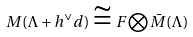Convert formula to latex. <formula><loc_0><loc_0><loc_500><loc_500>M ( \Lambda + h ^ { \vee } d ) \cong F \bigotimes \bar { M } ( \Lambda )</formula> 